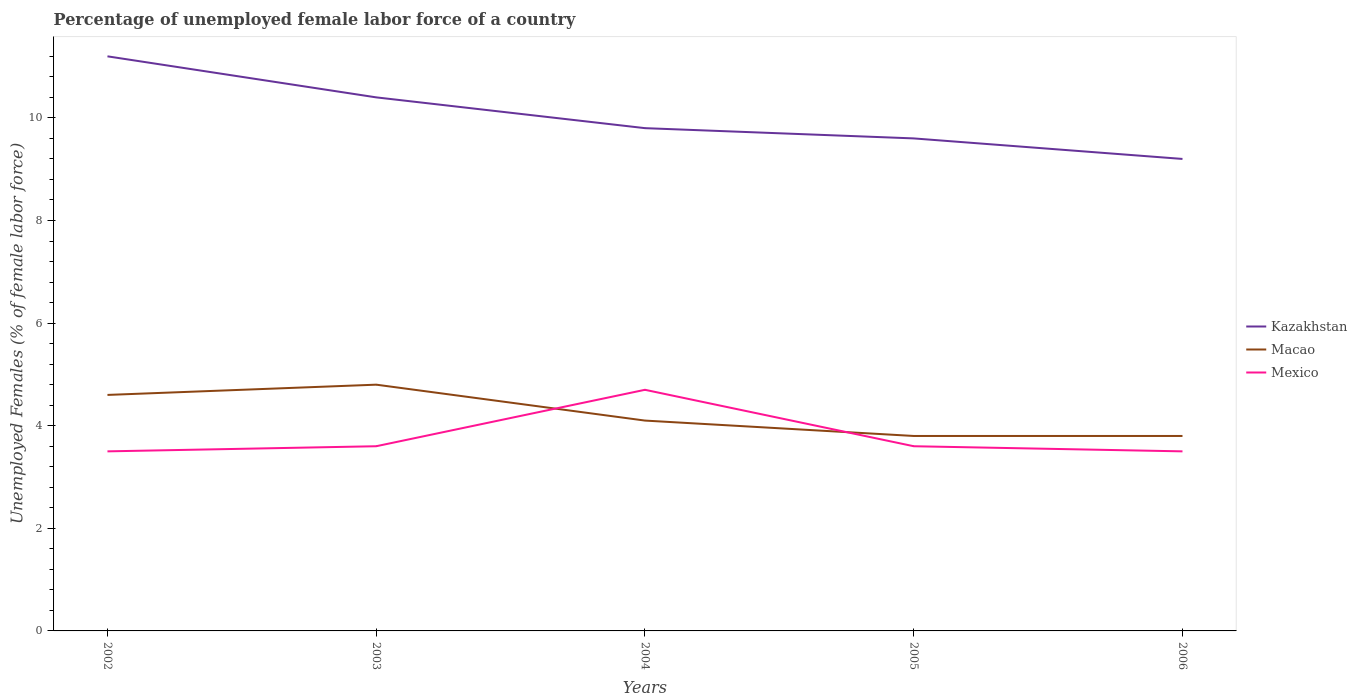Across all years, what is the maximum percentage of unemployed female labor force in Macao?
Keep it short and to the point. 3.8. In which year was the percentage of unemployed female labor force in Mexico maximum?
Make the answer very short. 2002. What is the total percentage of unemployed female labor force in Kazakhstan in the graph?
Give a very brief answer. 2. What is the difference between the highest and the second highest percentage of unemployed female labor force in Mexico?
Provide a short and direct response. 1.2. How many lines are there?
Your answer should be compact. 3. How many years are there in the graph?
Give a very brief answer. 5. What is the difference between two consecutive major ticks on the Y-axis?
Make the answer very short. 2. Are the values on the major ticks of Y-axis written in scientific E-notation?
Ensure brevity in your answer.  No. Where does the legend appear in the graph?
Your answer should be very brief. Center right. What is the title of the graph?
Your answer should be compact. Percentage of unemployed female labor force of a country. What is the label or title of the X-axis?
Offer a very short reply. Years. What is the label or title of the Y-axis?
Ensure brevity in your answer.  Unemployed Females (% of female labor force). What is the Unemployed Females (% of female labor force) of Kazakhstan in 2002?
Your response must be concise. 11.2. What is the Unemployed Females (% of female labor force) of Macao in 2002?
Provide a short and direct response. 4.6. What is the Unemployed Females (% of female labor force) of Mexico in 2002?
Offer a terse response. 3.5. What is the Unemployed Females (% of female labor force) of Kazakhstan in 2003?
Offer a terse response. 10.4. What is the Unemployed Females (% of female labor force) of Macao in 2003?
Your answer should be very brief. 4.8. What is the Unemployed Females (% of female labor force) in Mexico in 2003?
Your answer should be very brief. 3.6. What is the Unemployed Females (% of female labor force) in Kazakhstan in 2004?
Make the answer very short. 9.8. What is the Unemployed Females (% of female labor force) in Macao in 2004?
Offer a terse response. 4.1. What is the Unemployed Females (% of female labor force) of Mexico in 2004?
Provide a short and direct response. 4.7. What is the Unemployed Females (% of female labor force) in Kazakhstan in 2005?
Offer a terse response. 9.6. What is the Unemployed Females (% of female labor force) of Macao in 2005?
Keep it short and to the point. 3.8. What is the Unemployed Females (% of female labor force) of Mexico in 2005?
Provide a succinct answer. 3.6. What is the Unemployed Females (% of female labor force) of Kazakhstan in 2006?
Provide a succinct answer. 9.2. What is the Unemployed Females (% of female labor force) of Macao in 2006?
Your answer should be compact. 3.8. What is the Unemployed Females (% of female labor force) in Mexico in 2006?
Your response must be concise. 3.5. Across all years, what is the maximum Unemployed Females (% of female labor force) in Kazakhstan?
Your response must be concise. 11.2. Across all years, what is the maximum Unemployed Females (% of female labor force) in Macao?
Offer a very short reply. 4.8. Across all years, what is the maximum Unemployed Females (% of female labor force) of Mexico?
Provide a short and direct response. 4.7. Across all years, what is the minimum Unemployed Females (% of female labor force) of Kazakhstan?
Your response must be concise. 9.2. Across all years, what is the minimum Unemployed Females (% of female labor force) in Macao?
Make the answer very short. 3.8. What is the total Unemployed Females (% of female labor force) in Kazakhstan in the graph?
Your answer should be compact. 50.2. What is the total Unemployed Females (% of female labor force) of Macao in the graph?
Offer a very short reply. 21.1. What is the total Unemployed Females (% of female labor force) in Mexico in the graph?
Your answer should be compact. 18.9. What is the difference between the Unemployed Females (% of female labor force) in Kazakhstan in 2002 and that in 2003?
Provide a short and direct response. 0.8. What is the difference between the Unemployed Females (% of female labor force) in Macao in 2002 and that in 2003?
Give a very brief answer. -0.2. What is the difference between the Unemployed Females (% of female labor force) in Mexico in 2002 and that in 2003?
Ensure brevity in your answer.  -0.1. What is the difference between the Unemployed Females (% of female labor force) in Macao in 2002 and that in 2004?
Ensure brevity in your answer.  0.5. What is the difference between the Unemployed Females (% of female labor force) of Mexico in 2002 and that in 2004?
Provide a succinct answer. -1.2. What is the difference between the Unemployed Females (% of female labor force) in Kazakhstan in 2002 and that in 2006?
Your response must be concise. 2. What is the difference between the Unemployed Females (% of female labor force) in Mexico in 2002 and that in 2006?
Provide a succinct answer. 0. What is the difference between the Unemployed Females (% of female labor force) in Macao in 2003 and that in 2004?
Your answer should be very brief. 0.7. What is the difference between the Unemployed Females (% of female labor force) in Mexico in 2003 and that in 2004?
Keep it short and to the point. -1.1. What is the difference between the Unemployed Females (% of female labor force) of Kazakhstan in 2003 and that in 2005?
Keep it short and to the point. 0.8. What is the difference between the Unemployed Females (% of female labor force) in Macao in 2003 and that in 2005?
Offer a terse response. 1. What is the difference between the Unemployed Females (% of female labor force) of Kazakhstan in 2003 and that in 2006?
Make the answer very short. 1.2. What is the difference between the Unemployed Females (% of female labor force) of Macao in 2003 and that in 2006?
Give a very brief answer. 1. What is the difference between the Unemployed Females (% of female labor force) of Macao in 2004 and that in 2005?
Keep it short and to the point. 0.3. What is the difference between the Unemployed Females (% of female labor force) of Mexico in 2004 and that in 2005?
Provide a succinct answer. 1.1. What is the difference between the Unemployed Females (% of female labor force) in Kazakhstan in 2004 and that in 2006?
Keep it short and to the point. 0.6. What is the difference between the Unemployed Females (% of female labor force) of Macao in 2004 and that in 2006?
Provide a short and direct response. 0.3. What is the difference between the Unemployed Females (% of female labor force) of Kazakhstan in 2002 and the Unemployed Females (% of female labor force) of Mexico in 2003?
Your response must be concise. 7.6. What is the difference between the Unemployed Females (% of female labor force) in Macao in 2002 and the Unemployed Females (% of female labor force) in Mexico in 2003?
Your answer should be compact. 1. What is the difference between the Unemployed Females (% of female labor force) in Kazakhstan in 2002 and the Unemployed Females (% of female labor force) in Macao in 2004?
Your answer should be very brief. 7.1. What is the difference between the Unemployed Females (% of female labor force) in Kazakhstan in 2002 and the Unemployed Females (% of female labor force) in Mexico in 2004?
Offer a very short reply. 6.5. What is the difference between the Unemployed Females (% of female labor force) in Macao in 2002 and the Unemployed Females (% of female labor force) in Mexico in 2004?
Ensure brevity in your answer.  -0.1. What is the difference between the Unemployed Females (% of female labor force) of Kazakhstan in 2002 and the Unemployed Females (% of female labor force) of Macao in 2006?
Offer a terse response. 7.4. What is the difference between the Unemployed Females (% of female labor force) of Kazakhstan in 2003 and the Unemployed Females (% of female labor force) of Mexico in 2004?
Give a very brief answer. 5.7. What is the difference between the Unemployed Females (% of female labor force) of Macao in 2003 and the Unemployed Females (% of female labor force) of Mexico in 2006?
Your answer should be very brief. 1.3. What is the difference between the Unemployed Females (% of female labor force) of Kazakhstan in 2004 and the Unemployed Females (% of female labor force) of Macao in 2005?
Ensure brevity in your answer.  6. What is the difference between the Unemployed Females (% of female labor force) in Kazakhstan in 2004 and the Unemployed Females (% of female labor force) in Macao in 2006?
Provide a short and direct response. 6. What is the difference between the Unemployed Females (% of female labor force) of Macao in 2004 and the Unemployed Females (% of female labor force) of Mexico in 2006?
Your answer should be very brief. 0.6. What is the difference between the Unemployed Females (% of female labor force) in Kazakhstan in 2005 and the Unemployed Females (% of female labor force) in Macao in 2006?
Make the answer very short. 5.8. What is the difference between the Unemployed Females (% of female labor force) of Macao in 2005 and the Unemployed Females (% of female labor force) of Mexico in 2006?
Provide a short and direct response. 0.3. What is the average Unemployed Females (% of female labor force) of Kazakhstan per year?
Keep it short and to the point. 10.04. What is the average Unemployed Females (% of female labor force) of Macao per year?
Provide a short and direct response. 4.22. What is the average Unemployed Females (% of female labor force) in Mexico per year?
Ensure brevity in your answer.  3.78. In the year 2002, what is the difference between the Unemployed Females (% of female labor force) of Macao and Unemployed Females (% of female labor force) of Mexico?
Offer a terse response. 1.1. In the year 2003, what is the difference between the Unemployed Females (% of female labor force) in Kazakhstan and Unemployed Females (% of female labor force) in Macao?
Give a very brief answer. 5.6. In the year 2004, what is the difference between the Unemployed Females (% of female labor force) in Kazakhstan and Unemployed Females (% of female labor force) in Mexico?
Offer a terse response. 5.1. In the year 2004, what is the difference between the Unemployed Females (% of female labor force) in Macao and Unemployed Females (% of female labor force) in Mexico?
Keep it short and to the point. -0.6. In the year 2005, what is the difference between the Unemployed Females (% of female labor force) of Kazakhstan and Unemployed Females (% of female labor force) of Mexico?
Offer a very short reply. 6. In the year 2005, what is the difference between the Unemployed Females (% of female labor force) of Macao and Unemployed Females (% of female labor force) of Mexico?
Offer a terse response. 0.2. In the year 2006, what is the difference between the Unemployed Females (% of female labor force) of Kazakhstan and Unemployed Females (% of female labor force) of Macao?
Provide a succinct answer. 5.4. In the year 2006, what is the difference between the Unemployed Females (% of female labor force) of Kazakhstan and Unemployed Females (% of female labor force) of Mexico?
Give a very brief answer. 5.7. What is the ratio of the Unemployed Females (% of female labor force) in Macao in 2002 to that in 2003?
Your answer should be compact. 0.96. What is the ratio of the Unemployed Females (% of female labor force) of Mexico in 2002 to that in 2003?
Offer a terse response. 0.97. What is the ratio of the Unemployed Females (% of female labor force) of Macao in 2002 to that in 2004?
Your response must be concise. 1.12. What is the ratio of the Unemployed Females (% of female labor force) in Mexico in 2002 to that in 2004?
Your answer should be very brief. 0.74. What is the ratio of the Unemployed Females (% of female labor force) in Kazakhstan in 2002 to that in 2005?
Your answer should be very brief. 1.17. What is the ratio of the Unemployed Females (% of female labor force) in Macao in 2002 to that in 2005?
Your response must be concise. 1.21. What is the ratio of the Unemployed Females (% of female labor force) in Mexico in 2002 to that in 2005?
Give a very brief answer. 0.97. What is the ratio of the Unemployed Females (% of female labor force) of Kazakhstan in 2002 to that in 2006?
Offer a terse response. 1.22. What is the ratio of the Unemployed Females (% of female labor force) of Macao in 2002 to that in 2006?
Provide a succinct answer. 1.21. What is the ratio of the Unemployed Females (% of female labor force) in Mexico in 2002 to that in 2006?
Provide a succinct answer. 1. What is the ratio of the Unemployed Females (% of female labor force) in Kazakhstan in 2003 to that in 2004?
Make the answer very short. 1.06. What is the ratio of the Unemployed Females (% of female labor force) in Macao in 2003 to that in 2004?
Give a very brief answer. 1.17. What is the ratio of the Unemployed Females (% of female labor force) of Mexico in 2003 to that in 2004?
Offer a terse response. 0.77. What is the ratio of the Unemployed Females (% of female labor force) in Macao in 2003 to that in 2005?
Your answer should be compact. 1.26. What is the ratio of the Unemployed Females (% of female labor force) in Kazakhstan in 2003 to that in 2006?
Offer a terse response. 1.13. What is the ratio of the Unemployed Females (% of female labor force) of Macao in 2003 to that in 2006?
Give a very brief answer. 1.26. What is the ratio of the Unemployed Females (% of female labor force) in Mexico in 2003 to that in 2006?
Make the answer very short. 1.03. What is the ratio of the Unemployed Females (% of female labor force) in Kazakhstan in 2004 to that in 2005?
Offer a terse response. 1.02. What is the ratio of the Unemployed Females (% of female labor force) in Macao in 2004 to that in 2005?
Give a very brief answer. 1.08. What is the ratio of the Unemployed Females (% of female labor force) of Mexico in 2004 to that in 2005?
Offer a very short reply. 1.31. What is the ratio of the Unemployed Females (% of female labor force) of Kazakhstan in 2004 to that in 2006?
Your answer should be very brief. 1.07. What is the ratio of the Unemployed Females (% of female labor force) of Macao in 2004 to that in 2006?
Provide a succinct answer. 1.08. What is the ratio of the Unemployed Females (% of female labor force) of Mexico in 2004 to that in 2006?
Ensure brevity in your answer.  1.34. What is the ratio of the Unemployed Females (% of female labor force) in Kazakhstan in 2005 to that in 2006?
Your answer should be very brief. 1.04. What is the ratio of the Unemployed Females (% of female labor force) in Macao in 2005 to that in 2006?
Offer a very short reply. 1. What is the ratio of the Unemployed Females (% of female labor force) in Mexico in 2005 to that in 2006?
Provide a succinct answer. 1.03. What is the difference between the highest and the second highest Unemployed Females (% of female labor force) of Macao?
Offer a very short reply. 0.2. 